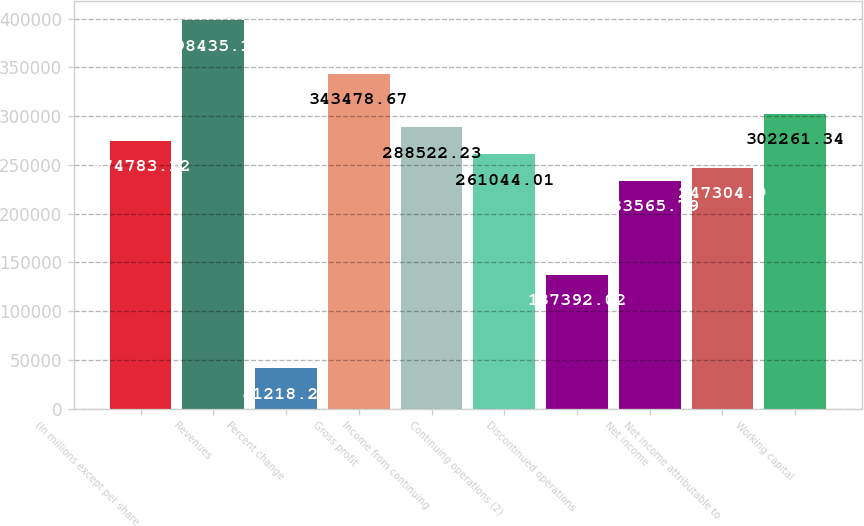Convert chart. <chart><loc_0><loc_0><loc_500><loc_500><bar_chart><fcel>(In millions except per share<fcel>Revenues<fcel>Percent change<fcel>Gross profit<fcel>Income from continuing<fcel>Continuing operations (2)<fcel>Discontinued operations<fcel>Net income<fcel>Net income attributable to<fcel>Working capital<nl><fcel>274783<fcel>398435<fcel>41218.2<fcel>343479<fcel>288522<fcel>261044<fcel>137392<fcel>233566<fcel>247305<fcel>302261<nl></chart> 